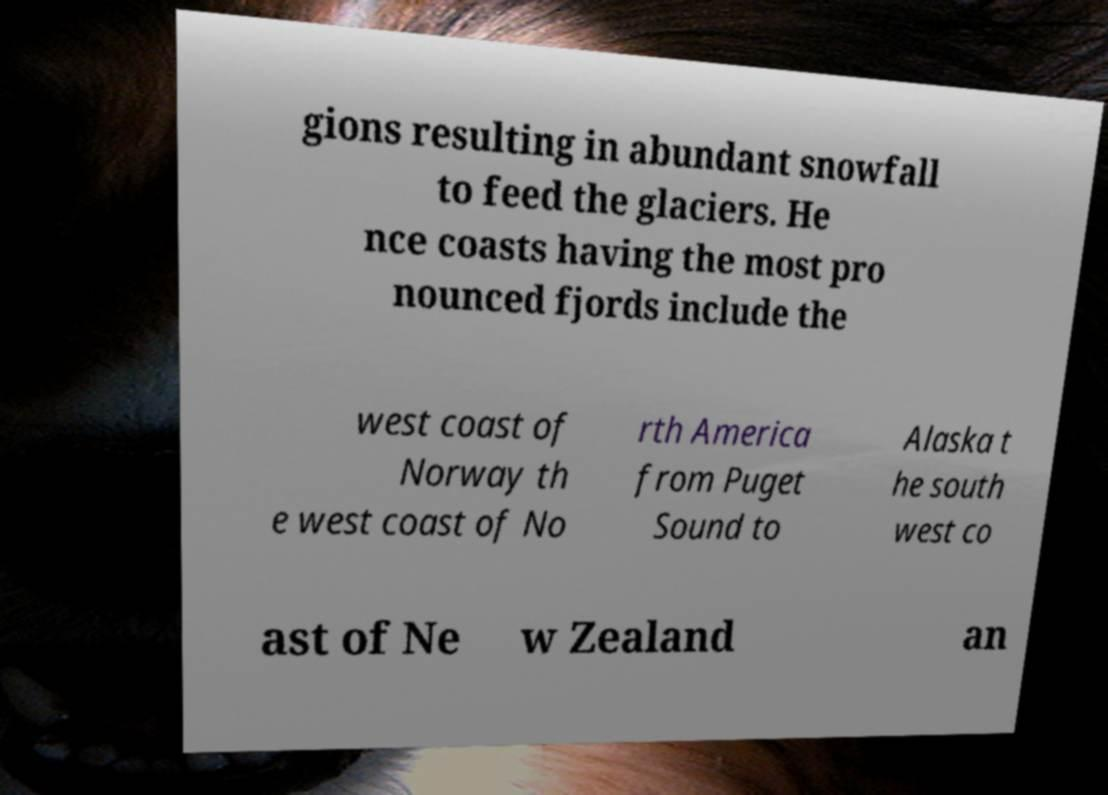Can you read and provide the text displayed in the image?This photo seems to have some interesting text. Can you extract and type it out for me? gions resulting in abundant snowfall to feed the glaciers. He nce coasts having the most pro nounced fjords include the west coast of Norway th e west coast of No rth America from Puget Sound to Alaska t he south west co ast of Ne w Zealand an 